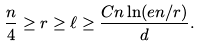Convert formula to latex. <formula><loc_0><loc_0><loc_500><loc_500>\frac { n } { 4 } \geq r \geq \ell \geq \frac { C n \ln ( e n / r ) } { d } .</formula> 